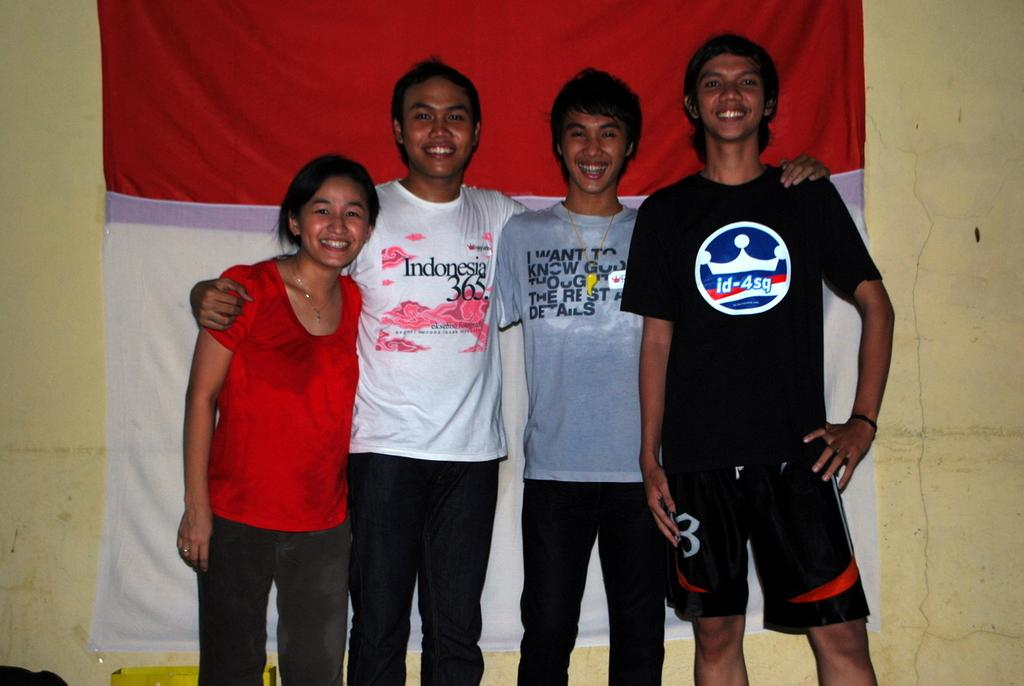<image>
Relay a brief, clear account of the picture shown. A guy is wearing a white shirt with Indonesia 365 on the front. 